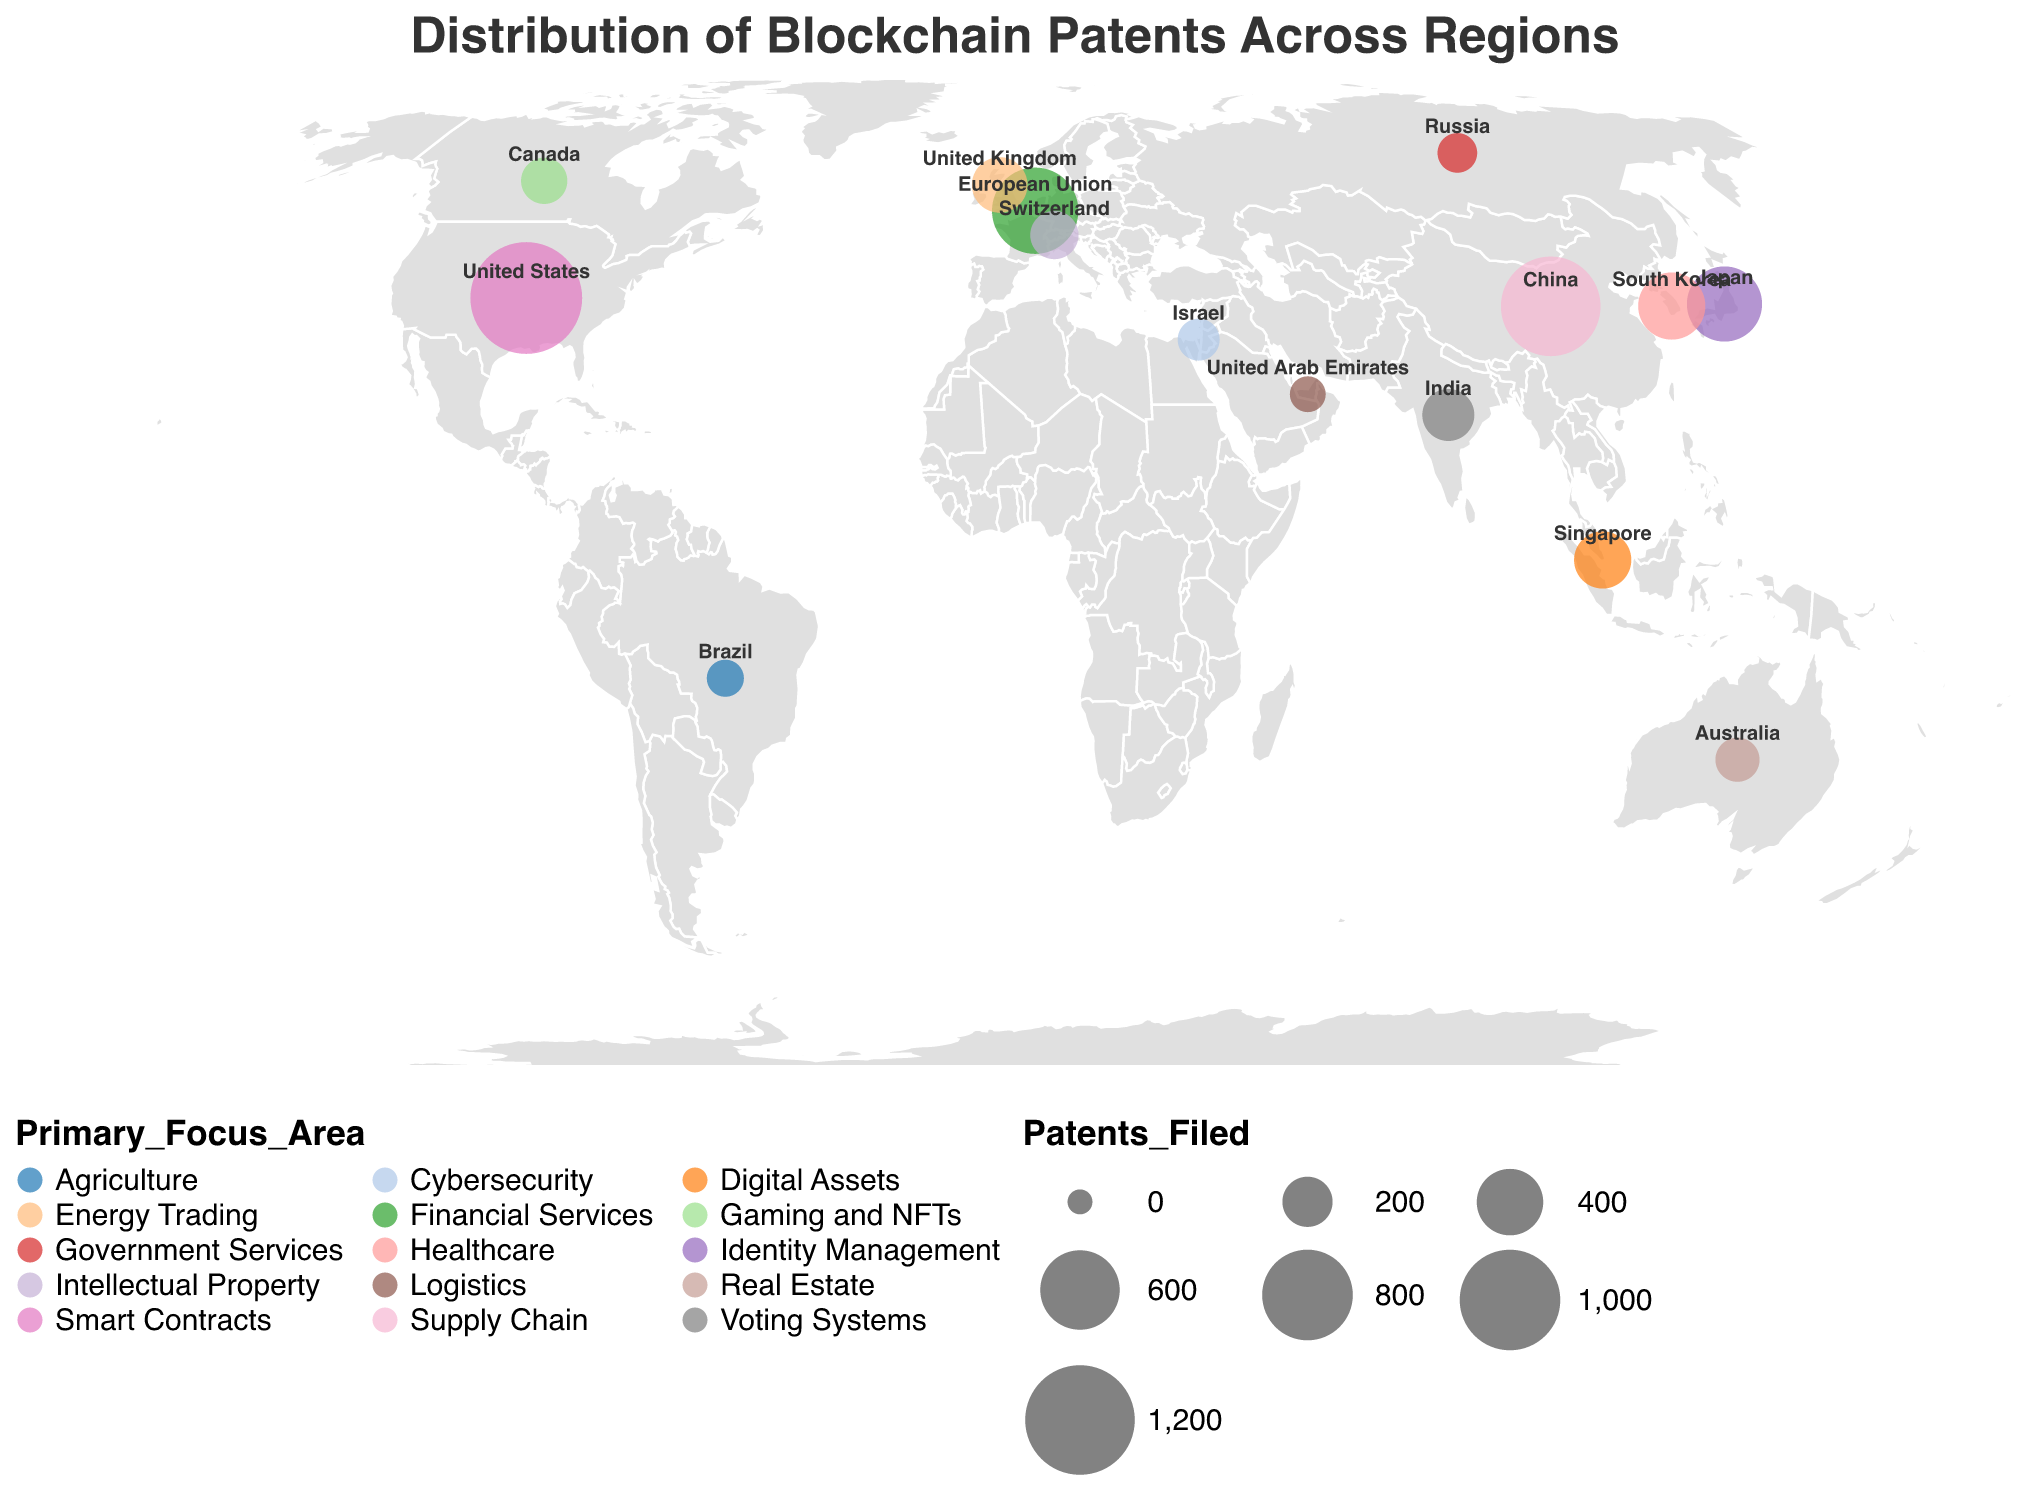what is the title of the figure? The title is usually placed at the top of the figure and summarizes the content of the visual. Here, it is displayed clearly at the top.
Answer: Distribution of Blockchain Patents Across Regions Which region has filed the highest number of blockchain patents? By looking at the figure, you can identify the region with the largest circle, as its size is proportional to the number of patents filed.
Answer: United States How many blockchain patents were filed in Japan? By finding the circle that represents Japan on the map and looking at the corresponding number, you can ascertain the number of patents.
Answer: 530 What is the primary focus area of blockchain patents in South Korea? Each circle is colored uniquely to represent the primary focus area. By identifying the circle for South Korea and checking its color in the legend, you can determine the focus area.
Answer: Healthcare Which regions have a primary focus area on financial services? Find the circles with the corresponding color in the legend for financial services and identify the associated regions.
Answer: European Union What is the total number of blockchain patents filed in the top three regions combined? The top three regions based on the circle size are the United States, China, and European Union. Add their patent counts: 1250 (United States) + 980 (China) + 720 (European Union)
Answer: 2950 Compare the number of blockchain patents filed in India and Canada. Which country has more? Locate the circles for India and Canada, and compare the numbers next to them.
Answer: India (220) Which region has a primary focus on digital assets, and how many patents have they filed? Identify the region associated with the digital assets color in the legend, then locate its corresponding circle and number.
Answer: Singapore, 280 How many regions have filed fewer than 200 blockchain patents? Count the number of regions with circles smaller than 200 in size by checking their patent count.
Answer: 9 What is the primary focus area for blockchain patents filed in Switzerland? Associating the color and region on the map, you find the primary focus area for Switzerland's patents.
Answer: Intellectual Property 